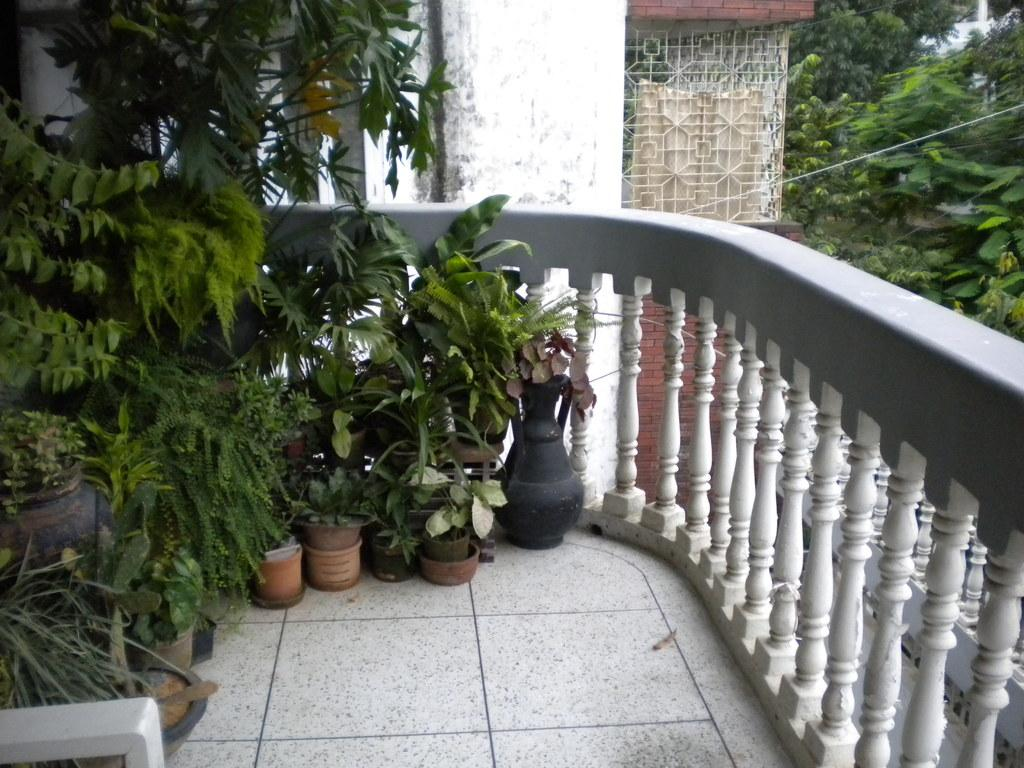What structure is present on the edge of the building in the image? There is a balcony in the image. What can be seen on the left side of the balcony? There are plants on the left side of the balcony. What type of vegetation is visible on the right side of the image? There are trees on the right side of the image. What is visible in the background of the image? There is a building in the background of the image. What type of card is being used to lead the nation in the image? There is no card or nation depicted in the image; it features a balcony with plants and a background with a building. 